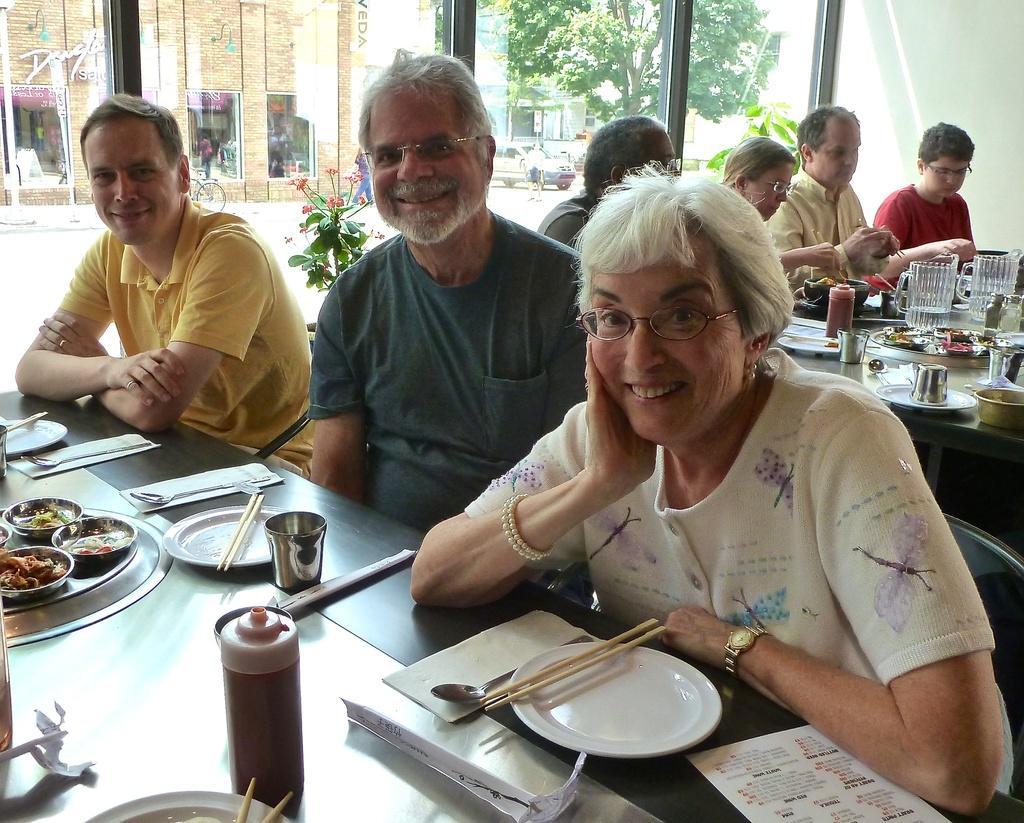How would you summarize this image in a sentence or two? There are people sitting on chairs and we can see plates,sticks,food,jars,glasses,spoons and objects on tables. In the background we can see glass,through this glass we can see people,wall,tree,plants and vehicles. 